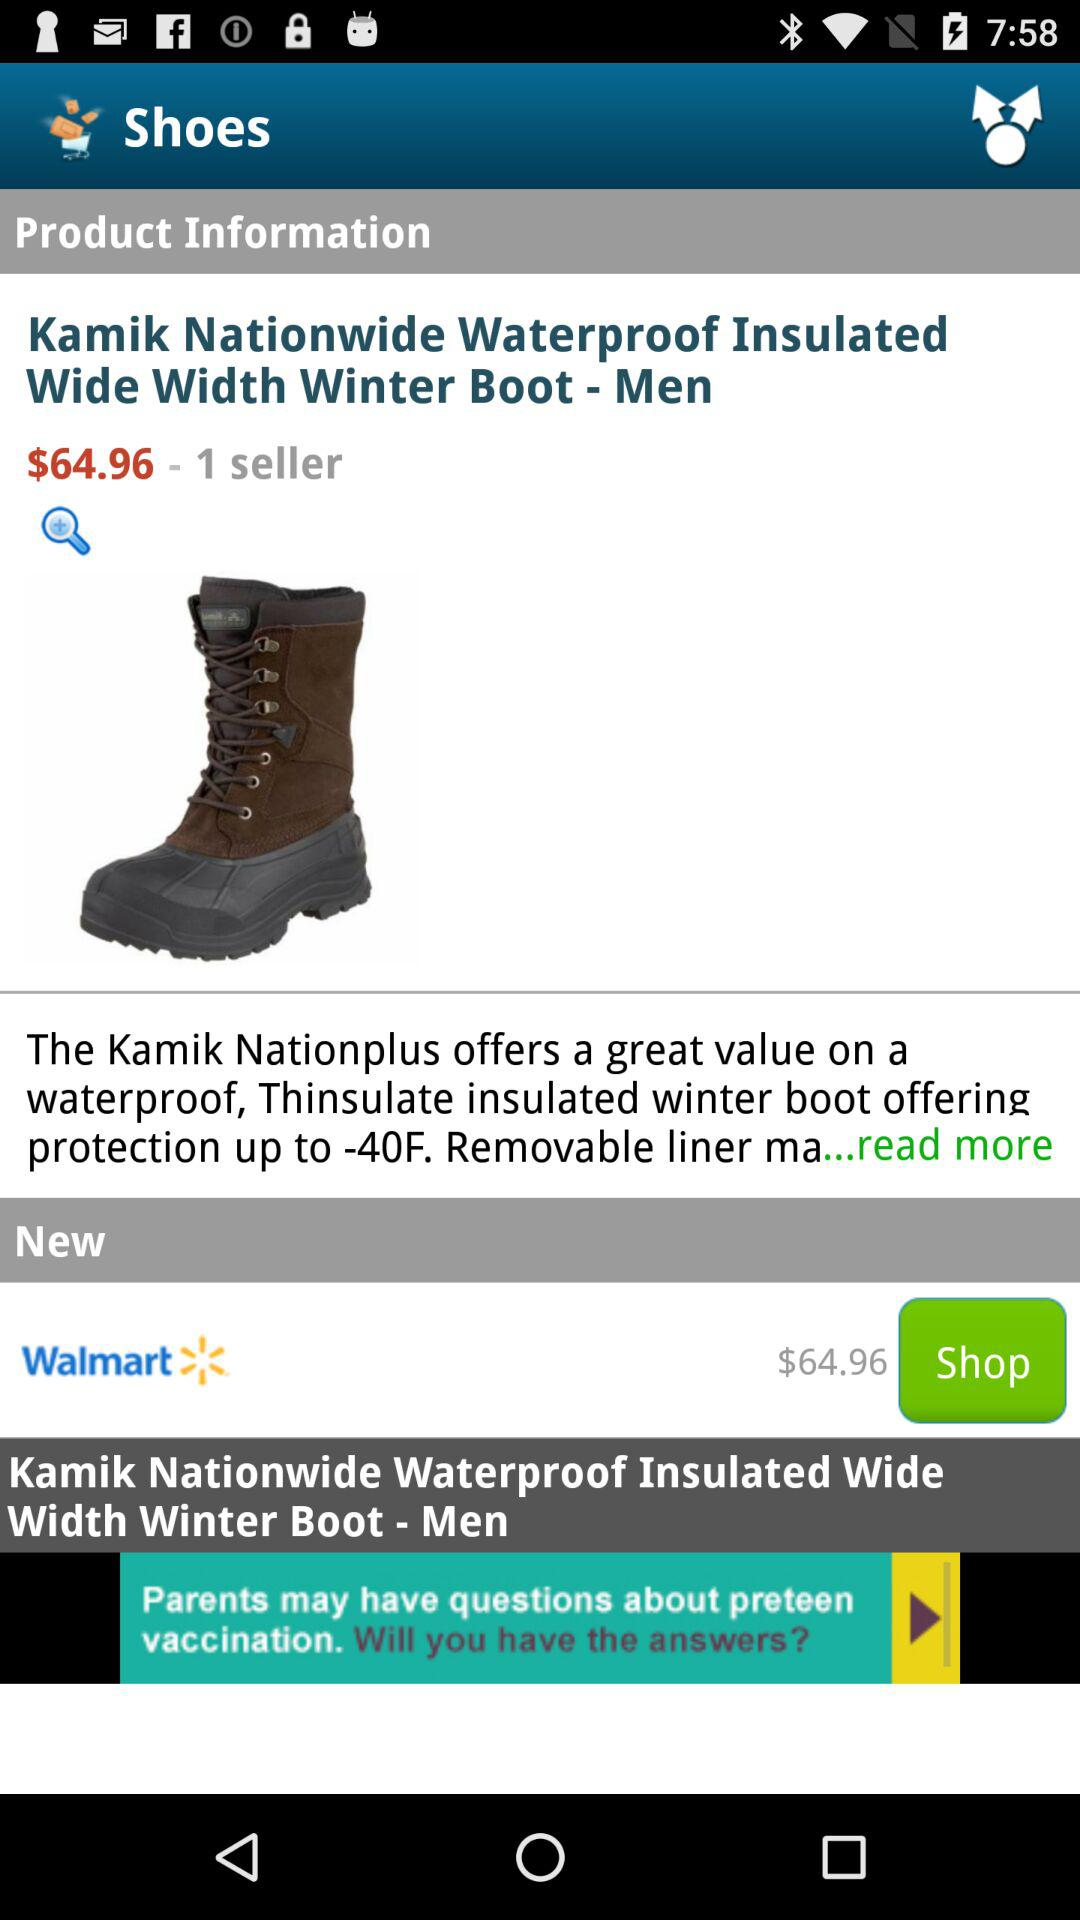What is the cost? The cost is 64.96 dollars. 